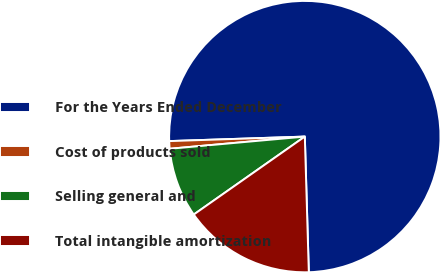Convert chart to OTSL. <chart><loc_0><loc_0><loc_500><loc_500><pie_chart><fcel>For the Years Ended December<fcel>Cost of products sold<fcel>Selling general and<fcel>Total intangible amortization<nl><fcel>75.06%<fcel>0.9%<fcel>8.31%<fcel>15.73%<nl></chart> 